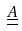Convert formula to latex. <formula><loc_0><loc_0><loc_500><loc_500>\underline { \underline { A } }</formula> 